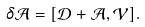<formula> <loc_0><loc_0><loc_500><loc_500>\delta \mathcal { A } = [ \mathcal { D } + \mathcal { A } , \mathcal { V } ] .</formula> 